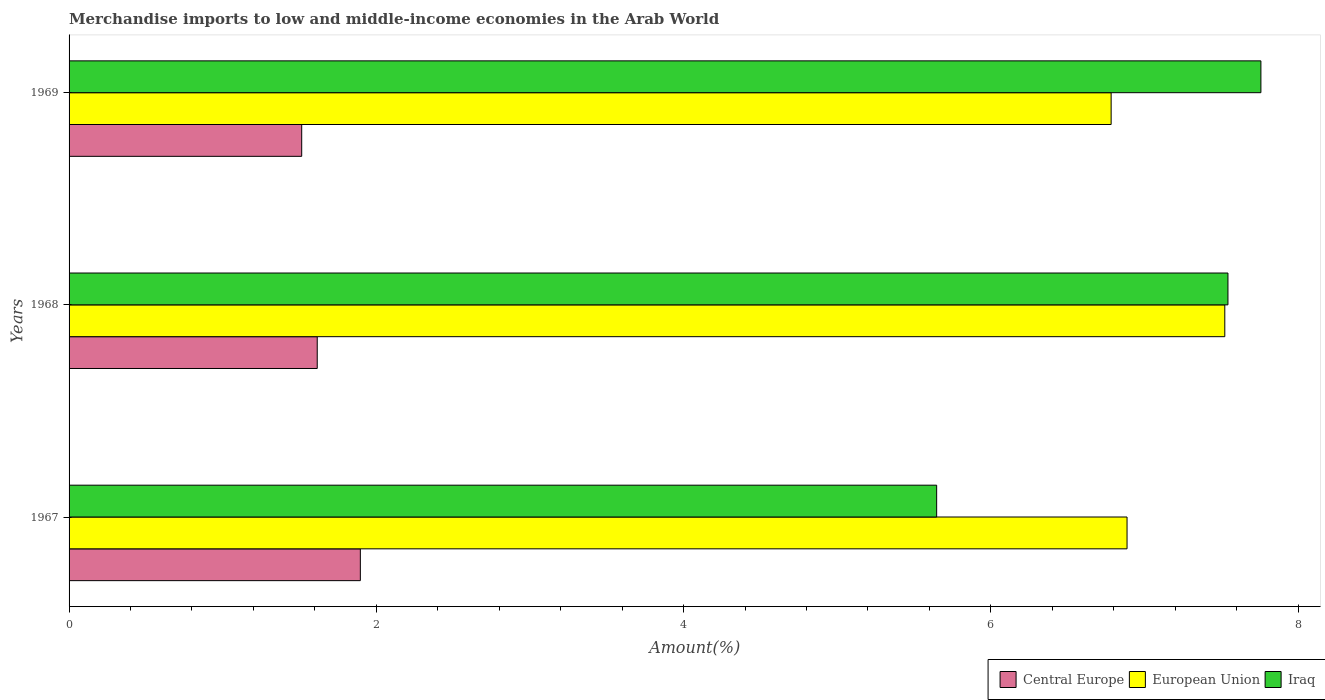Are the number of bars per tick equal to the number of legend labels?
Give a very brief answer. Yes. Are the number of bars on each tick of the Y-axis equal?
Your answer should be very brief. Yes. How many bars are there on the 3rd tick from the top?
Offer a terse response. 3. How many bars are there on the 1st tick from the bottom?
Give a very brief answer. 3. What is the label of the 3rd group of bars from the top?
Keep it short and to the point. 1967. In how many cases, is the number of bars for a given year not equal to the number of legend labels?
Keep it short and to the point. 0. What is the percentage of amount earned from merchandise imports in European Union in 1969?
Your answer should be very brief. 6.78. Across all years, what is the maximum percentage of amount earned from merchandise imports in European Union?
Ensure brevity in your answer.  7.52. Across all years, what is the minimum percentage of amount earned from merchandise imports in Central Europe?
Provide a short and direct response. 1.51. In which year was the percentage of amount earned from merchandise imports in European Union maximum?
Your answer should be compact. 1968. In which year was the percentage of amount earned from merchandise imports in Iraq minimum?
Offer a terse response. 1967. What is the total percentage of amount earned from merchandise imports in Central Europe in the graph?
Your answer should be compact. 5.03. What is the difference between the percentage of amount earned from merchandise imports in European Union in 1967 and that in 1969?
Your answer should be very brief. 0.1. What is the difference between the percentage of amount earned from merchandise imports in Iraq in 1969 and the percentage of amount earned from merchandise imports in European Union in 1968?
Provide a succinct answer. 0.24. What is the average percentage of amount earned from merchandise imports in European Union per year?
Offer a very short reply. 7.06. In the year 1969, what is the difference between the percentage of amount earned from merchandise imports in Central Europe and percentage of amount earned from merchandise imports in European Union?
Keep it short and to the point. -5.27. What is the ratio of the percentage of amount earned from merchandise imports in Iraq in 1967 to that in 1968?
Keep it short and to the point. 0.75. What is the difference between the highest and the second highest percentage of amount earned from merchandise imports in Iraq?
Offer a terse response. 0.21. What is the difference between the highest and the lowest percentage of amount earned from merchandise imports in Iraq?
Offer a very short reply. 2.11. Is the sum of the percentage of amount earned from merchandise imports in European Union in 1968 and 1969 greater than the maximum percentage of amount earned from merchandise imports in Central Europe across all years?
Offer a terse response. Yes. What does the 1st bar from the bottom in 1968 represents?
Offer a terse response. Central Europe. How many years are there in the graph?
Keep it short and to the point. 3. Does the graph contain any zero values?
Your answer should be compact. No. Does the graph contain grids?
Offer a very short reply. No. How many legend labels are there?
Your answer should be compact. 3. What is the title of the graph?
Provide a succinct answer. Merchandise imports to low and middle-income economies in the Arab World. What is the label or title of the X-axis?
Your answer should be very brief. Amount(%). What is the label or title of the Y-axis?
Offer a terse response. Years. What is the Amount(%) in Central Europe in 1967?
Offer a very short reply. 1.9. What is the Amount(%) of European Union in 1967?
Your answer should be very brief. 6.89. What is the Amount(%) in Iraq in 1967?
Offer a very short reply. 5.65. What is the Amount(%) of Central Europe in 1968?
Your answer should be compact. 1.62. What is the Amount(%) of European Union in 1968?
Ensure brevity in your answer.  7.52. What is the Amount(%) of Iraq in 1968?
Keep it short and to the point. 7.54. What is the Amount(%) in Central Europe in 1969?
Give a very brief answer. 1.51. What is the Amount(%) of European Union in 1969?
Provide a succinct answer. 6.78. What is the Amount(%) of Iraq in 1969?
Provide a succinct answer. 7.76. Across all years, what is the maximum Amount(%) in Central Europe?
Give a very brief answer. 1.9. Across all years, what is the maximum Amount(%) of European Union?
Offer a very short reply. 7.52. Across all years, what is the maximum Amount(%) in Iraq?
Offer a very short reply. 7.76. Across all years, what is the minimum Amount(%) of Central Europe?
Make the answer very short. 1.51. Across all years, what is the minimum Amount(%) of European Union?
Your response must be concise. 6.78. Across all years, what is the minimum Amount(%) in Iraq?
Offer a very short reply. 5.65. What is the total Amount(%) of Central Europe in the graph?
Provide a short and direct response. 5.03. What is the total Amount(%) in European Union in the graph?
Keep it short and to the point. 21.19. What is the total Amount(%) in Iraq in the graph?
Your response must be concise. 20.95. What is the difference between the Amount(%) in Central Europe in 1967 and that in 1968?
Offer a terse response. 0.28. What is the difference between the Amount(%) in European Union in 1967 and that in 1968?
Provide a short and direct response. -0.64. What is the difference between the Amount(%) of Iraq in 1967 and that in 1968?
Offer a terse response. -1.9. What is the difference between the Amount(%) in Central Europe in 1967 and that in 1969?
Make the answer very short. 0.38. What is the difference between the Amount(%) in European Union in 1967 and that in 1969?
Make the answer very short. 0.1. What is the difference between the Amount(%) of Iraq in 1967 and that in 1969?
Keep it short and to the point. -2.11. What is the difference between the Amount(%) of Central Europe in 1968 and that in 1969?
Give a very brief answer. 0.1. What is the difference between the Amount(%) in European Union in 1968 and that in 1969?
Your response must be concise. 0.74. What is the difference between the Amount(%) of Iraq in 1968 and that in 1969?
Offer a very short reply. -0.21. What is the difference between the Amount(%) of Central Europe in 1967 and the Amount(%) of European Union in 1968?
Keep it short and to the point. -5.63. What is the difference between the Amount(%) in Central Europe in 1967 and the Amount(%) in Iraq in 1968?
Ensure brevity in your answer.  -5.65. What is the difference between the Amount(%) in European Union in 1967 and the Amount(%) in Iraq in 1968?
Offer a very short reply. -0.66. What is the difference between the Amount(%) of Central Europe in 1967 and the Amount(%) of European Union in 1969?
Give a very brief answer. -4.89. What is the difference between the Amount(%) of Central Europe in 1967 and the Amount(%) of Iraq in 1969?
Your answer should be very brief. -5.86. What is the difference between the Amount(%) of European Union in 1967 and the Amount(%) of Iraq in 1969?
Ensure brevity in your answer.  -0.87. What is the difference between the Amount(%) of Central Europe in 1968 and the Amount(%) of European Union in 1969?
Offer a very short reply. -5.17. What is the difference between the Amount(%) in Central Europe in 1968 and the Amount(%) in Iraq in 1969?
Offer a very short reply. -6.14. What is the difference between the Amount(%) of European Union in 1968 and the Amount(%) of Iraq in 1969?
Keep it short and to the point. -0.23. What is the average Amount(%) in Central Europe per year?
Your response must be concise. 1.68. What is the average Amount(%) in European Union per year?
Offer a very short reply. 7.06. What is the average Amount(%) in Iraq per year?
Your answer should be compact. 6.98. In the year 1967, what is the difference between the Amount(%) in Central Europe and Amount(%) in European Union?
Provide a succinct answer. -4.99. In the year 1967, what is the difference between the Amount(%) in Central Europe and Amount(%) in Iraq?
Provide a succinct answer. -3.75. In the year 1967, what is the difference between the Amount(%) in European Union and Amount(%) in Iraq?
Give a very brief answer. 1.24. In the year 1968, what is the difference between the Amount(%) of Central Europe and Amount(%) of European Union?
Offer a very short reply. -5.91. In the year 1968, what is the difference between the Amount(%) in Central Europe and Amount(%) in Iraq?
Ensure brevity in your answer.  -5.93. In the year 1968, what is the difference between the Amount(%) in European Union and Amount(%) in Iraq?
Provide a succinct answer. -0.02. In the year 1969, what is the difference between the Amount(%) of Central Europe and Amount(%) of European Union?
Offer a terse response. -5.27. In the year 1969, what is the difference between the Amount(%) in Central Europe and Amount(%) in Iraq?
Ensure brevity in your answer.  -6.24. In the year 1969, what is the difference between the Amount(%) in European Union and Amount(%) in Iraq?
Keep it short and to the point. -0.97. What is the ratio of the Amount(%) of Central Europe in 1967 to that in 1968?
Your answer should be compact. 1.17. What is the ratio of the Amount(%) of European Union in 1967 to that in 1968?
Ensure brevity in your answer.  0.92. What is the ratio of the Amount(%) in Iraq in 1967 to that in 1968?
Keep it short and to the point. 0.75. What is the ratio of the Amount(%) in Central Europe in 1967 to that in 1969?
Make the answer very short. 1.25. What is the ratio of the Amount(%) of European Union in 1967 to that in 1969?
Your answer should be compact. 1.02. What is the ratio of the Amount(%) in Iraq in 1967 to that in 1969?
Provide a short and direct response. 0.73. What is the ratio of the Amount(%) in Central Europe in 1968 to that in 1969?
Give a very brief answer. 1.07. What is the ratio of the Amount(%) in European Union in 1968 to that in 1969?
Your answer should be very brief. 1.11. What is the ratio of the Amount(%) in Iraq in 1968 to that in 1969?
Offer a very short reply. 0.97. What is the difference between the highest and the second highest Amount(%) in Central Europe?
Offer a terse response. 0.28. What is the difference between the highest and the second highest Amount(%) in European Union?
Keep it short and to the point. 0.64. What is the difference between the highest and the second highest Amount(%) in Iraq?
Provide a short and direct response. 0.21. What is the difference between the highest and the lowest Amount(%) of Central Europe?
Provide a succinct answer. 0.38. What is the difference between the highest and the lowest Amount(%) of European Union?
Ensure brevity in your answer.  0.74. What is the difference between the highest and the lowest Amount(%) of Iraq?
Ensure brevity in your answer.  2.11. 